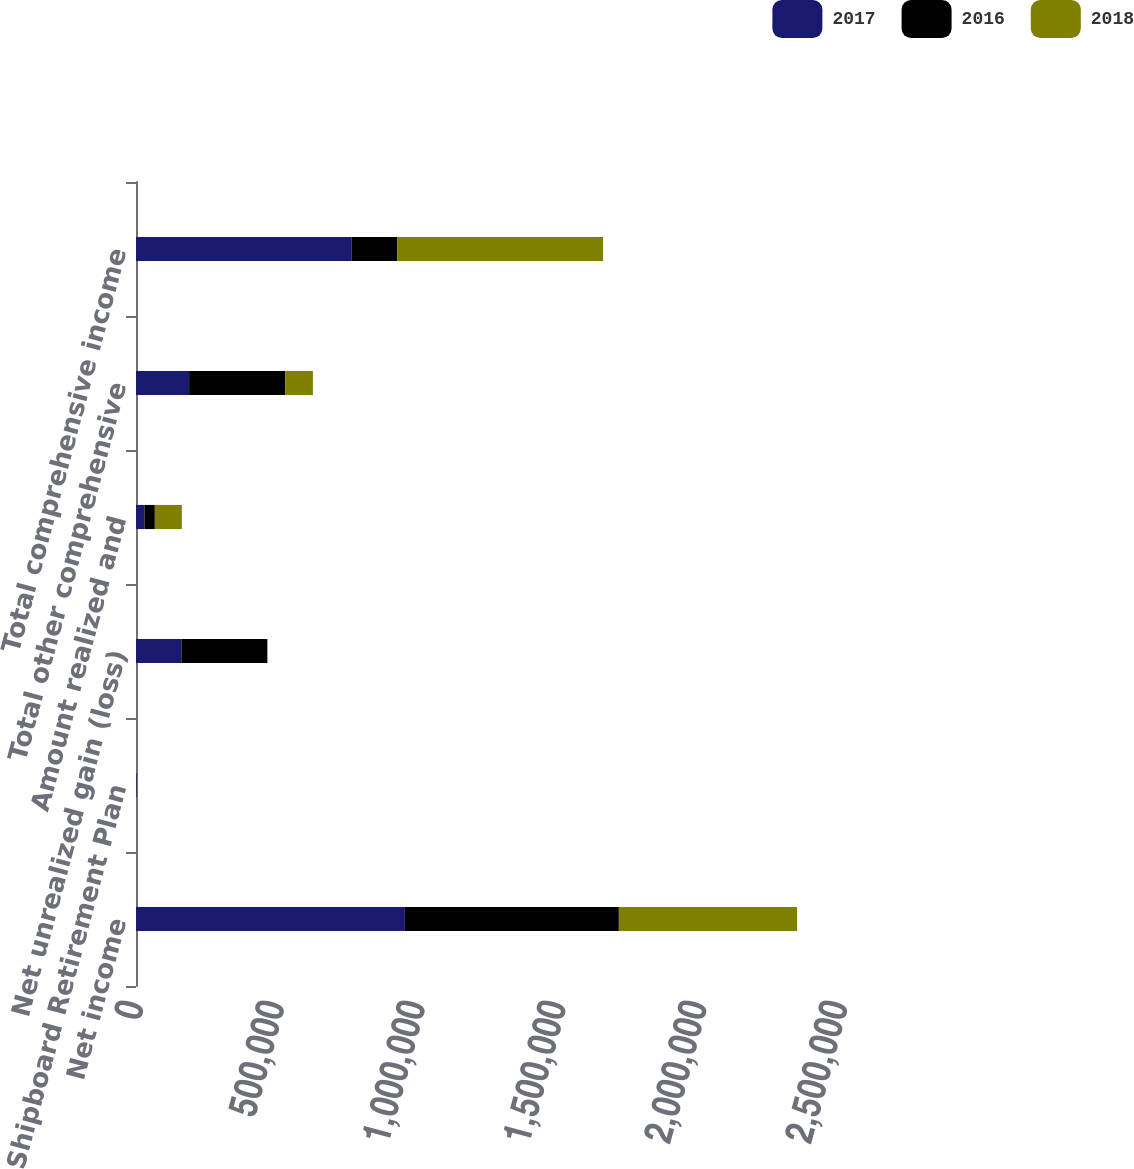<chart> <loc_0><loc_0><loc_500><loc_500><stacked_bar_chart><ecel><fcel>Net income<fcel>Shipboard Retirement Plan<fcel>Net unrealized gain (loss)<fcel>Amount realized and<fcel>Total other comprehensive<fcel>Total comprehensive income<nl><fcel>2017<fcel>954843<fcel>2697<fcel>161214<fcel>30096<fcel>188613<fcel>766230<nl><fcel>2016<fcel>759872<fcel>40<fcel>304684<fcel>36795<fcel>341439<fcel>161214<nl><fcel>2018<fcel>633085<fcel>497<fcel>1711<fcel>95969<fcel>98177<fcel>731262<nl></chart> 